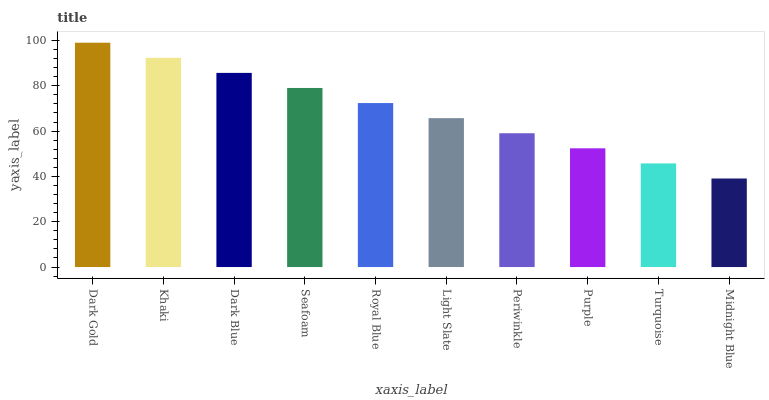Is Khaki the minimum?
Answer yes or no. No. Is Khaki the maximum?
Answer yes or no. No. Is Dark Gold greater than Khaki?
Answer yes or no. Yes. Is Khaki less than Dark Gold?
Answer yes or no. Yes. Is Khaki greater than Dark Gold?
Answer yes or no. No. Is Dark Gold less than Khaki?
Answer yes or no. No. Is Royal Blue the high median?
Answer yes or no. Yes. Is Light Slate the low median?
Answer yes or no. Yes. Is Dark Gold the high median?
Answer yes or no. No. Is Periwinkle the low median?
Answer yes or no. No. 